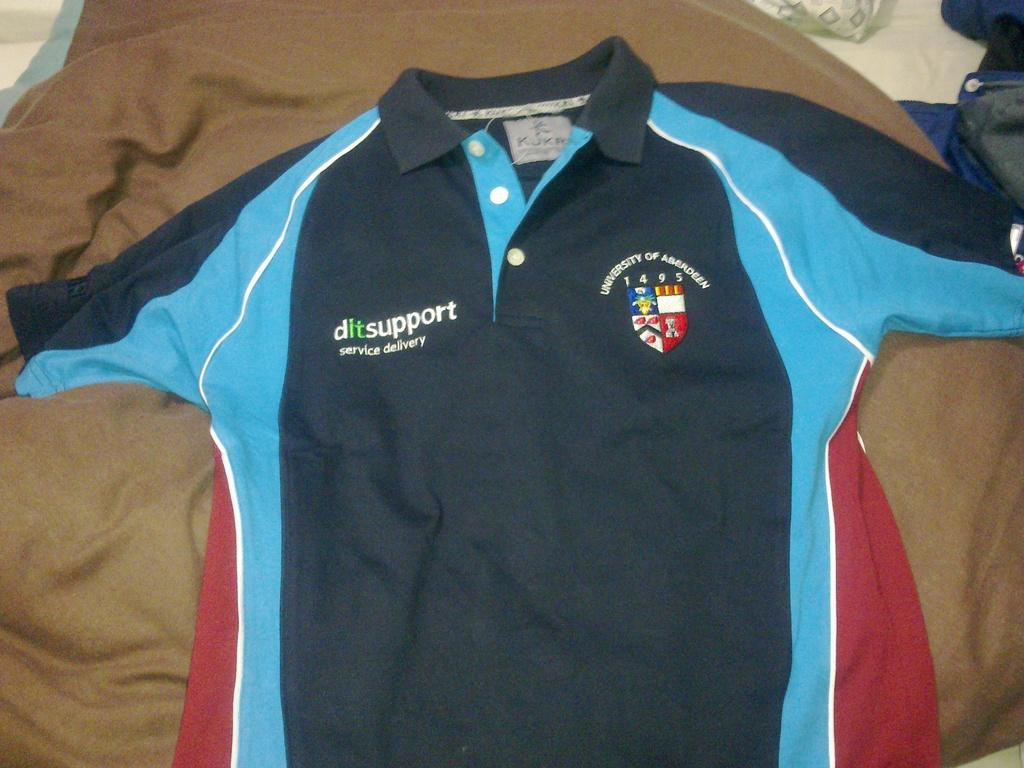<image>
Provide a brief description of the given image. Soccer jersey which says service delivery oni t. 